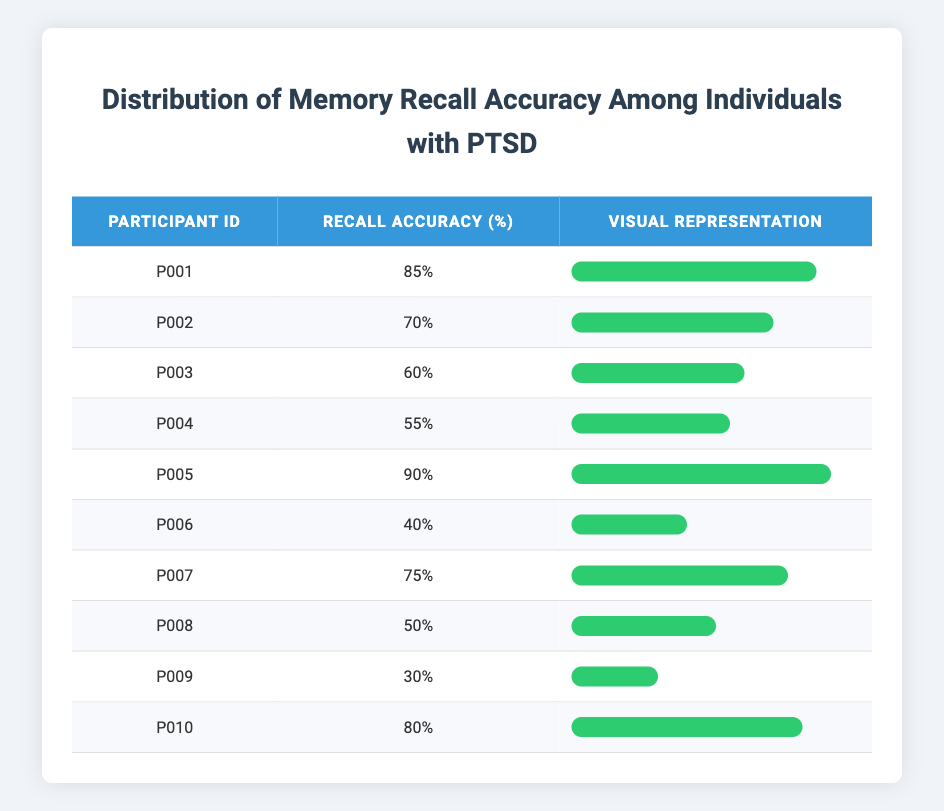What is the recall accuracy of Participant P005? In the table, look at the row corresponding to Participant P005, which shows a recall accuracy percentage of 90%.
Answer: 90% Which participant has the lowest recall accuracy? The row with the lowest percentage shows Participant P009, which has a recall accuracy of 30%.
Answer: P009 What is the average recall accuracy of all participants? First, sum the recall accuracy percentages: 85 + 70 + 60 + 55 + 90 + 40 + 75 + 50 + 30 + 80 =  730. There are 10 participants, so divide 730 by 10 to get an average of 73%.
Answer: 73% Is there any participant whose recall accuracy is above 80%? By examining the table, the accuracies for Participants P001 (85%) and P005 (90%) are both above 80%, confirming that there are participants in this category.
Answer: Yes How many participants have a recall accuracy of less than 50%? Look at the percentages in the table. The only participant with an accuracy below 50% is P009 with 30% and P006 with 40%, therefore there are 2 participants.
Answer: 2 What is the difference in recall accuracy between the highest and lowest performers? The highest performer, P005, has an accuracy of 90%, while the lowest, P009, has 30%. Subtract the lowest from the highest: 90 - 30 = 60.
Answer: 60 How many participants have recall accuracy percentages between 50% and 70%? By checking the table, Participants P002 (70%), P003 (60%), P004 (55%), and P008 (50%) fit within this range, giving a total of 4 participants.
Answer: 4 Which participant has a higher recall accuracy, P001 or P010? Compare the percentages: P001 has 85% and P010 has 80%. Clearly, P001 has a higher recall accuracy than P010.
Answer: P001 